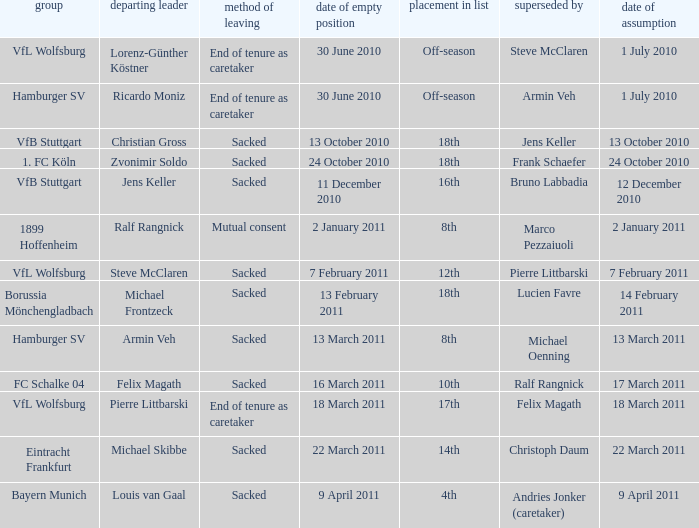Could you parse the entire table as a dict? {'header': ['group', 'departing leader', 'method of leaving', 'date of empty position', 'placement in list', 'superseded by', 'date of assumption'], 'rows': [['VfL Wolfsburg', 'Lorenz-Günther Köstner', 'End of tenure as caretaker', '30 June 2010', 'Off-season', 'Steve McClaren', '1 July 2010'], ['Hamburger SV', 'Ricardo Moniz', 'End of tenure as caretaker', '30 June 2010', 'Off-season', 'Armin Veh', '1 July 2010'], ['VfB Stuttgart', 'Christian Gross', 'Sacked', '13 October 2010', '18th', 'Jens Keller', '13 October 2010'], ['1. FC Köln', 'Zvonimir Soldo', 'Sacked', '24 October 2010', '18th', 'Frank Schaefer', '24 October 2010'], ['VfB Stuttgart', 'Jens Keller', 'Sacked', '11 December 2010', '16th', 'Bruno Labbadia', '12 December 2010'], ['1899 Hoffenheim', 'Ralf Rangnick', 'Mutual consent', '2 January 2011', '8th', 'Marco Pezzaiuoli', '2 January 2011'], ['VfL Wolfsburg', 'Steve McClaren', 'Sacked', '7 February 2011', '12th', 'Pierre Littbarski', '7 February 2011'], ['Borussia Mönchengladbach', 'Michael Frontzeck', 'Sacked', '13 February 2011', '18th', 'Lucien Favre', '14 February 2011'], ['Hamburger SV', 'Armin Veh', 'Sacked', '13 March 2011', '8th', 'Michael Oenning', '13 March 2011'], ['FC Schalke 04', 'Felix Magath', 'Sacked', '16 March 2011', '10th', 'Ralf Rangnick', '17 March 2011'], ['VfL Wolfsburg', 'Pierre Littbarski', 'End of tenure as caretaker', '18 March 2011', '17th', 'Felix Magath', '18 March 2011'], ['Eintracht Frankfurt', 'Michael Skibbe', 'Sacked', '22 March 2011', '14th', 'Christoph Daum', '22 March 2011'], ['Bayern Munich', 'Louis van Gaal', 'Sacked', '9 April 2011', '4th', 'Andries Jonker (caretaker)', '9 April 2011']]} When steve mcclaren is the replacer what is the manner of departure? End of tenure as caretaker. 